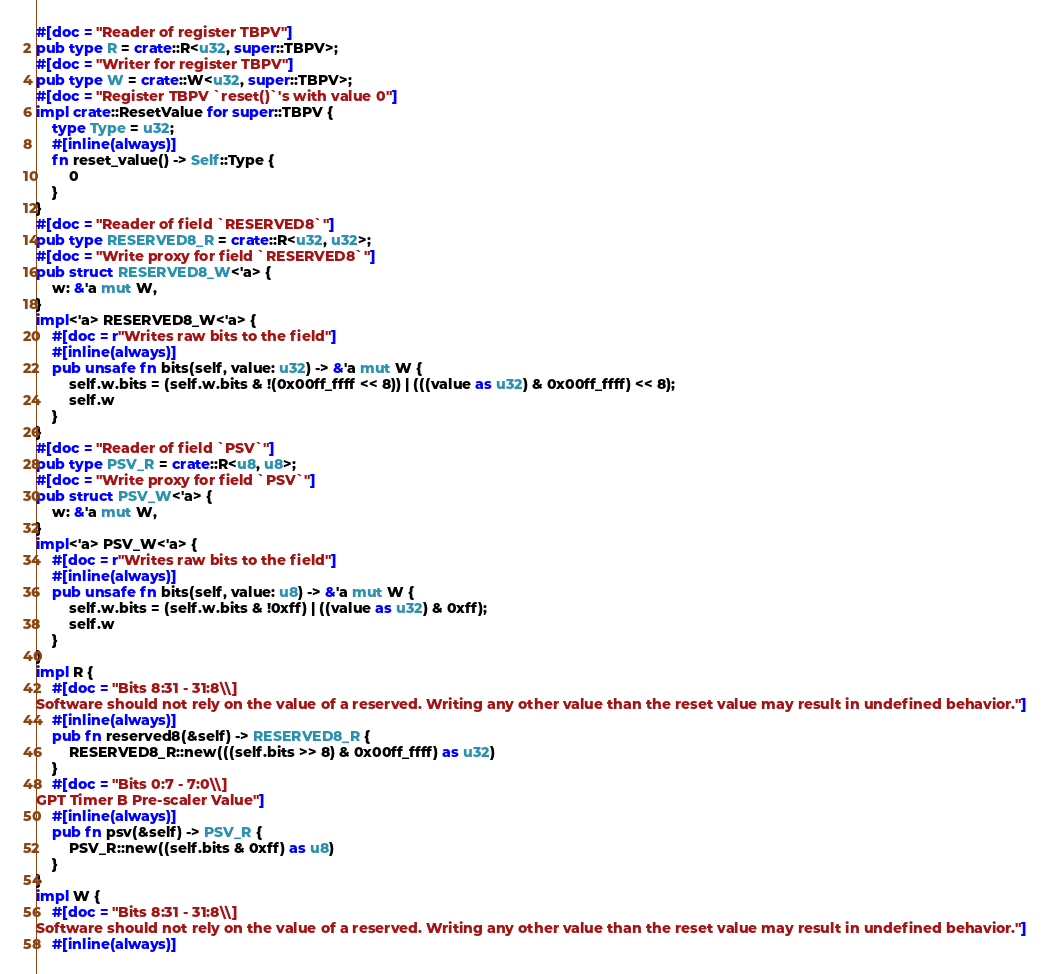Convert code to text. <code><loc_0><loc_0><loc_500><loc_500><_Rust_>#[doc = "Reader of register TBPV"]
pub type R = crate::R<u32, super::TBPV>;
#[doc = "Writer for register TBPV"]
pub type W = crate::W<u32, super::TBPV>;
#[doc = "Register TBPV `reset()`'s with value 0"]
impl crate::ResetValue for super::TBPV {
    type Type = u32;
    #[inline(always)]
    fn reset_value() -> Self::Type {
        0
    }
}
#[doc = "Reader of field `RESERVED8`"]
pub type RESERVED8_R = crate::R<u32, u32>;
#[doc = "Write proxy for field `RESERVED8`"]
pub struct RESERVED8_W<'a> {
    w: &'a mut W,
}
impl<'a> RESERVED8_W<'a> {
    #[doc = r"Writes raw bits to the field"]
    #[inline(always)]
    pub unsafe fn bits(self, value: u32) -> &'a mut W {
        self.w.bits = (self.w.bits & !(0x00ff_ffff << 8)) | (((value as u32) & 0x00ff_ffff) << 8);
        self.w
    }
}
#[doc = "Reader of field `PSV`"]
pub type PSV_R = crate::R<u8, u8>;
#[doc = "Write proxy for field `PSV`"]
pub struct PSV_W<'a> {
    w: &'a mut W,
}
impl<'a> PSV_W<'a> {
    #[doc = r"Writes raw bits to the field"]
    #[inline(always)]
    pub unsafe fn bits(self, value: u8) -> &'a mut W {
        self.w.bits = (self.w.bits & !0xff) | ((value as u32) & 0xff);
        self.w
    }
}
impl R {
    #[doc = "Bits 8:31 - 31:8\\]
Software should not rely on the value of a reserved. Writing any other value than the reset value may result in undefined behavior."]
    #[inline(always)]
    pub fn reserved8(&self) -> RESERVED8_R {
        RESERVED8_R::new(((self.bits >> 8) & 0x00ff_ffff) as u32)
    }
    #[doc = "Bits 0:7 - 7:0\\]
GPT Timer B Pre-scaler Value"]
    #[inline(always)]
    pub fn psv(&self) -> PSV_R {
        PSV_R::new((self.bits & 0xff) as u8)
    }
}
impl W {
    #[doc = "Bits 8:31 - 31:8\\]
Software should not rely on the value of a reserved. Writing any other value than the reset value may result in undefined behavior."]
    #[inline(always)]</code> 